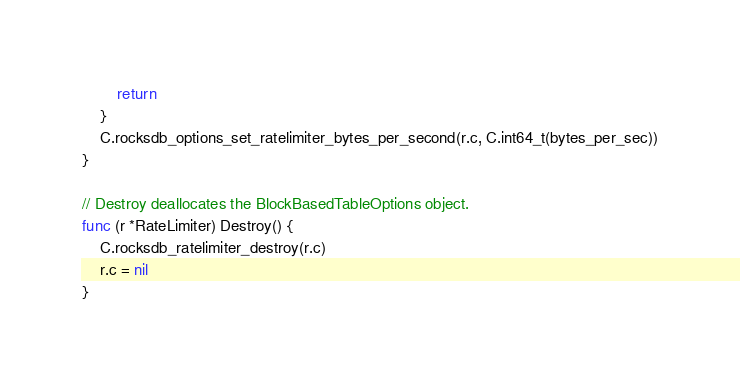<code> <loc_0><loc_0><loc_500><loc_500><_Go_>		return
	}
	C.rocksdb_options_set_ratelimiter_bytes_per_second(r.c, C.int64_t(bytes_per_sec))
}

// Destroy deallocates the BlockBasedTableOptions object.
func (r *RateLimiter) Destroy() {
	C.rocksdb_ratelimiter_destroy(r.c)
	r.c = nil
}
</code> 